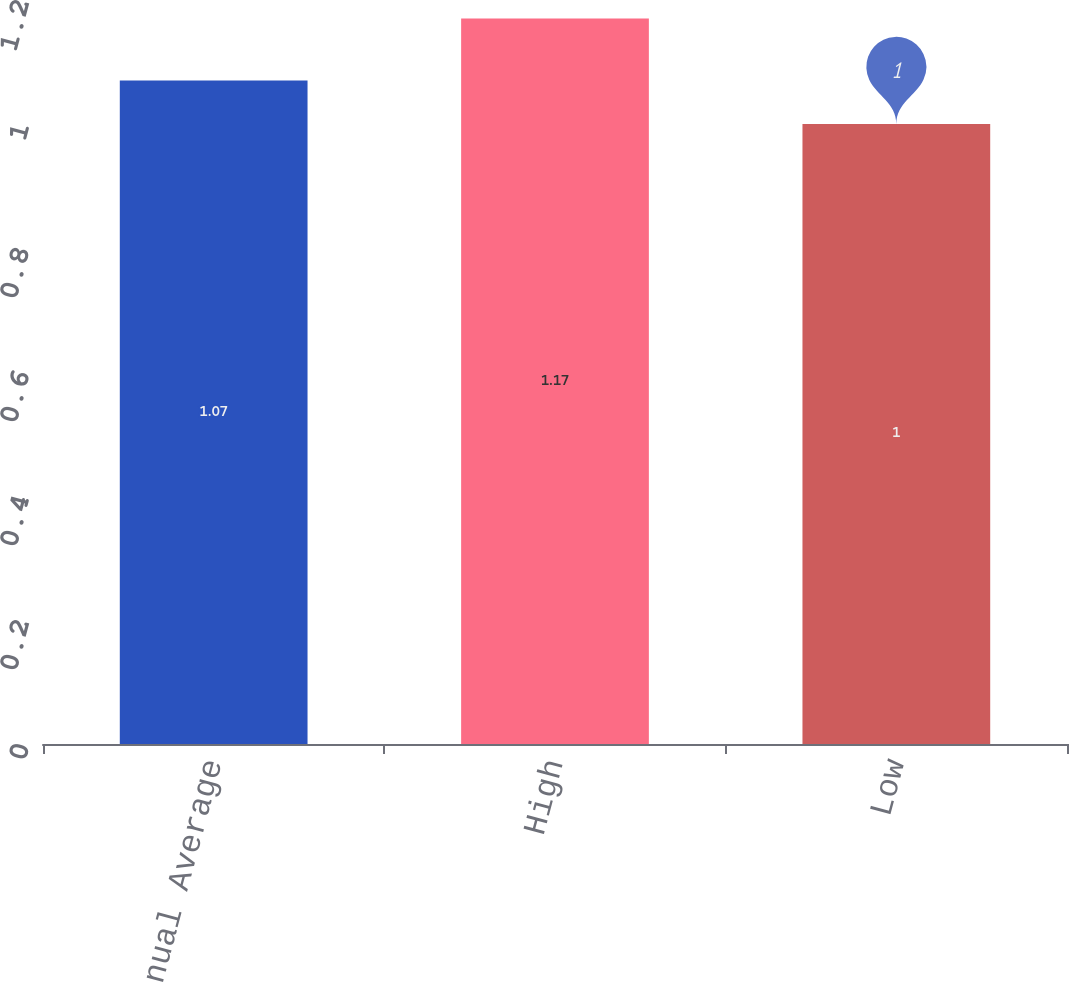<chart> <loc_0><loc_0><loc_500><loc_500><bar_chart><fcel>Annual Average<fcel>High<fcel>Low<nl><fcel>1.07<fcel>1.17<fcel>1<nl></chart> 